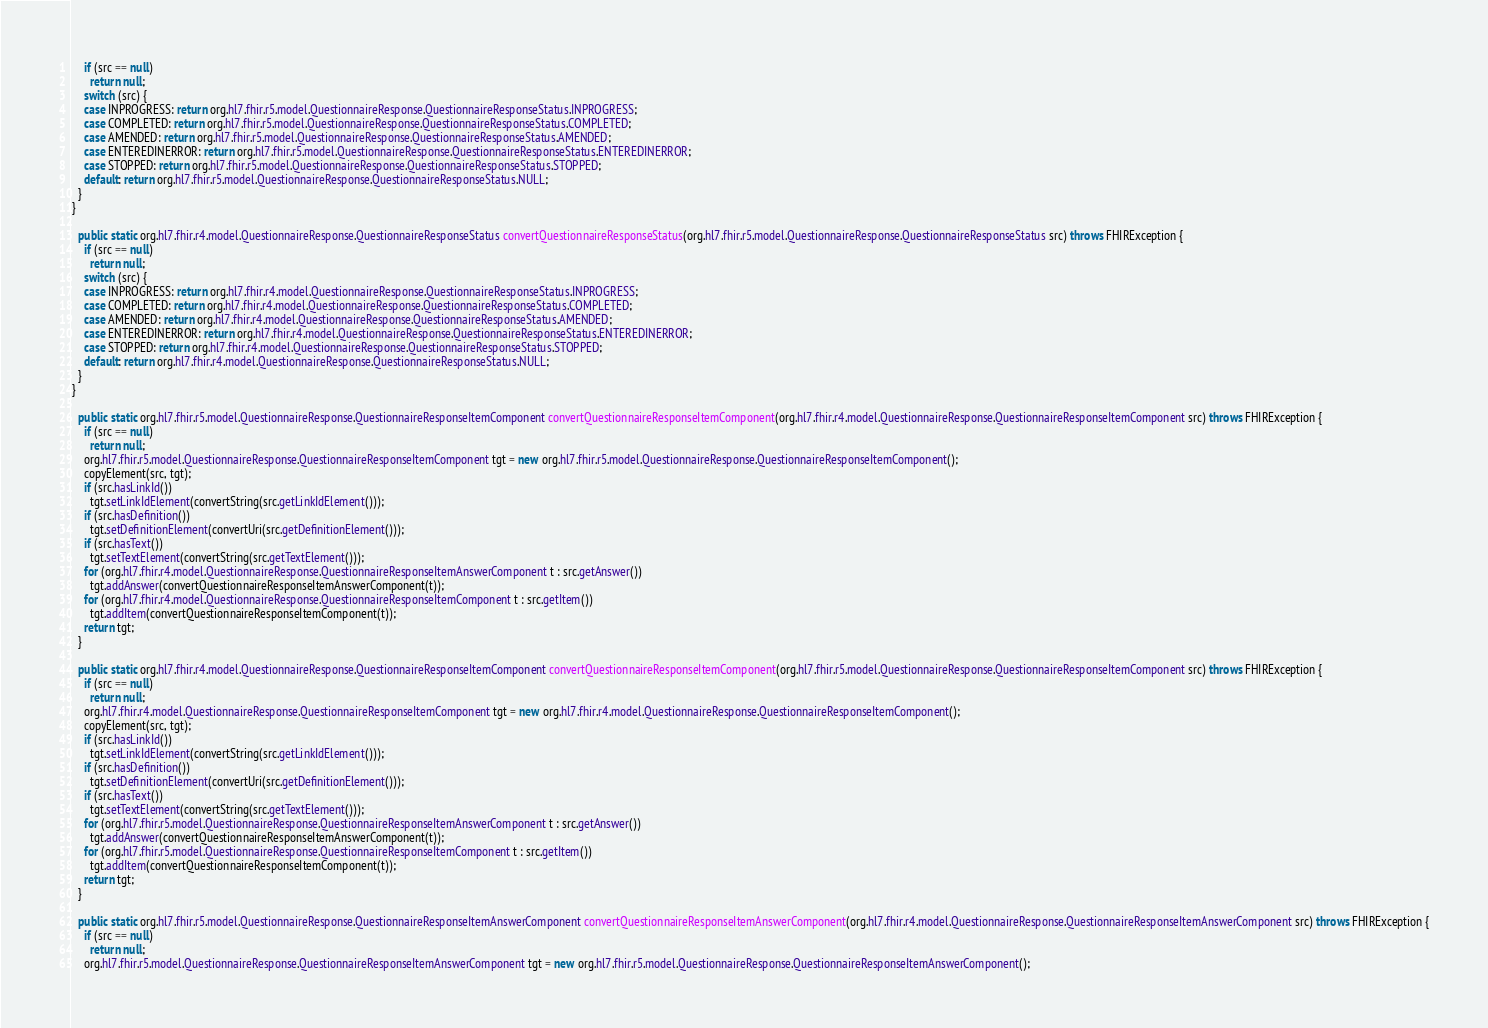Convert code to text. <code><loc_0><loc_0><loc_500><loc_500><_Java_>    if (src == null)
      return null;
    switch (src) {
    case INPROGRESS: return org.hl7.fhir.r5.model.QuestionnaireResponse.QuestionnaireResponseStatus.INPROGRESS;
    case COMPLETED: return org.hl7.fhir.r5.model.QuestionnaireResponse.QuestionnaireResponseStatus.COMPLETED;
    case AMENDED: return org.hl7.fhir.r5.model.QuestionnaireResponse.QuestionnaireResponseStatus.AMENDED;
    case ENTEREDINERROR: return org.hl7.fhir.r5.model.QuestionnaireResponse.QuestionnaireResponseStatus.ENTEREDINERROR;
    case STOPPED: return org.hl7.fhir.r5.model.QuestionnaireResponse.QuestionnaireResponseStatus.STOPPED;
    default: return org.hl7.fhir.r5.model.QuestionnaireResponse.QuestionnaireResponseStatus.NULL;
  }
}

  public static org.hl7.fhir.r4.model.QuestionnaireResponse.QuestionnaireResponseStatus convertQuestionnaireResponseStatus(org.hl7.fhir.r5.model.QuestionnaireResponse.QuestionnaireResponseStatus src) throws FHIRException {
    if (src == null)
      return null;
    switch (src) {
    case INPROGRESS: return org.hl7.fhir.r4.model.QuestionnaireResponse.QuestionnaireResponseStatus.INPROGRESS;
    case COMPLETED: return org.hl7.fhir.r4.model.QuestionnaireResponse.QuestionnaireResponseStatus.COMPLETED;
    case AMENDED: return org.hl7.fhir.r4.model.QuestionnaireResponse.QuestionnaireResponseStatus.AMENDED;
    case ENTEREDINERROR: return org.hl7.fhir.r4.model.QuestionnaireResponse.QuestionnaireResponseStatus.ENTEREDINERROR;
    case STOPPED: return org.hl7.fhir.r4.model.QuestionnaireResponse.QuestionnaireResponseStatus.STOPPED;
    default: return org.hl7.fhir.r4.model.QuestionnaireResponse.QuestionnaireResponseStatus.NULL;
  }
}

  public static org.hl7.fhir.r5.model.QuestionnaireResponse.QuestionnaireResponseItemComponent convertQuestionnaireResponseItemComponent(org.hl7.fhir.r4.model.QuestionnaireResponse.QuestionnaireResponseItemComponent src) throws FHIRException {
    if (src == null)
      return null;
    org.hl7.fhir.r5.model.QuestionnaireResponse.QuestionnaireResponseItemComponent tgt = new org.hl7.fhir.r5.model.QuestionnaireResponse.QuestionnaireResponseItemComponent();
    copyElement(src, tgt);
    if (src.hasLinkId())
      tgt.setLinkIdElement(convertString(src.getLinkIdElement()));
    if (src.hasDefinition())
      tgt.setDefinitionElement(convertUri(src.getDefinitionElement()));
    if (src.hasText())
      tgt.setTextElement(convertString(src.getTextElement()));
    for (org.hl7.fhir.r4.model.QuestionnaireResponse.QuestionnaireResponseItemAnswerComponent t : src.getAnswer())
      tgt.addAnswer(convertQuestionnaireResponseItemAnswerComponent(t));
    for (org.hl7.fhir.r4.model.QuestionnaireResponse.QuestionnaireResponseItemComponent t : src.getItem())
      tgt.addItem(convertQuestionnaireResponseItemComponent(t));
    return tgt;
  }

  public static org.hl7.fhir.r4.model.QuestionnaireResponse.QuestionnaireResponseItemComponent convertQuestionnaireResponseItemComponent(org.hl7.fhir.r5.model.QuestionnaireResponse.QuestionnaireResponseItemComponent src) throws FHIRException {
    if (src == null)
      return null;
    org.hl7.fhir.r4.model.QuestionnaireResponse.QuestionnaireResponseItemComponent tgt = new org.hl7.fhir.r4.model.QuestionnaireResponse.QuestionnaireResponseItemComponent();
    copyElement(src, tgt);
    if (src.hasLinkId())
      tgt.setLinkIdElement(convertString(src.getLinkIdElement()));
    if (src.hasDefinition())
      tgt.setDefinitionElement(convertUri(src.getDefinitionElement()));
    if (src.hasText())
      tgt.setTextElement(convertString(src.getTextElement()));
    for (org.hl7.fhir.r5.model.QuestionnaireResponse.QuestionnaireResponseItemAnswerComponent t : src.getAnswer())
      tgt.addAnswer(convertQuestionnaireResponseItemAnswerComponent(t));
    for (org.hl7.fhir.r5.model.QuestionnaireResponse.QuestionnaireResponseItemComponent t : src.getItem())
      tgt.addItem(convertQuestionnaireResponseItemComponent(t));
    return tgt;
  }

  public static org.hl7.fhir.r5.model.QuestionnaireResponse.QuestionnaireResponseItemAnswerComponent convertQuestionnaireResponseItemAnswerComponent(org.hl7.fhir.r4.model.QuestionnaireResponse.QuestionnaireResponseItemAnswerComponent src) throws FHIRException {
    if (src == null)
      return null;
    org.hl7.fhir.r5.model.QuestionnaireResponse.QuestionnaireResponseItemAnswerComponent tgt = new org.hl7.fhir.r5.model.QuestionnaireResponse.QuestionnaireResponseItemAnswerComponent();</code> 